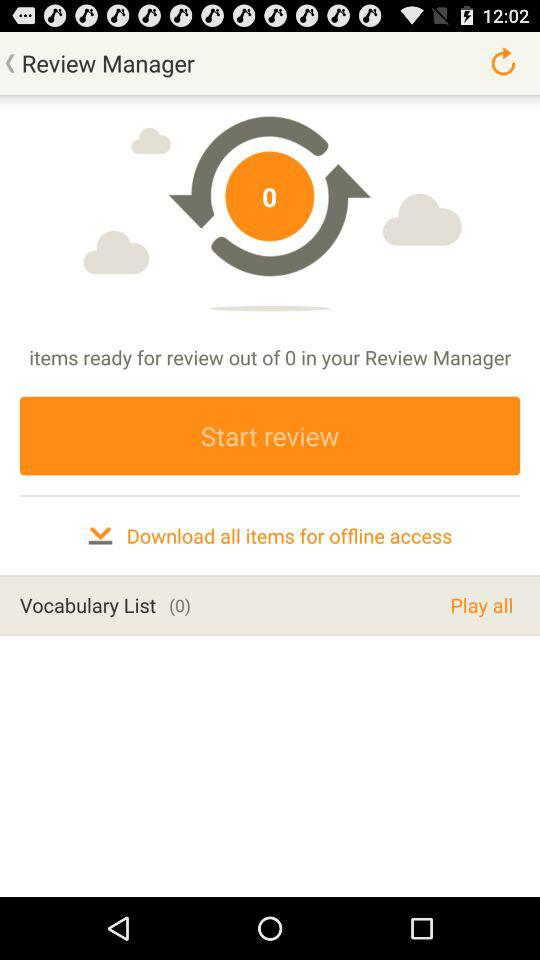Is there any item in the vocabulary list? There are 0 items in the vocabulary list. 